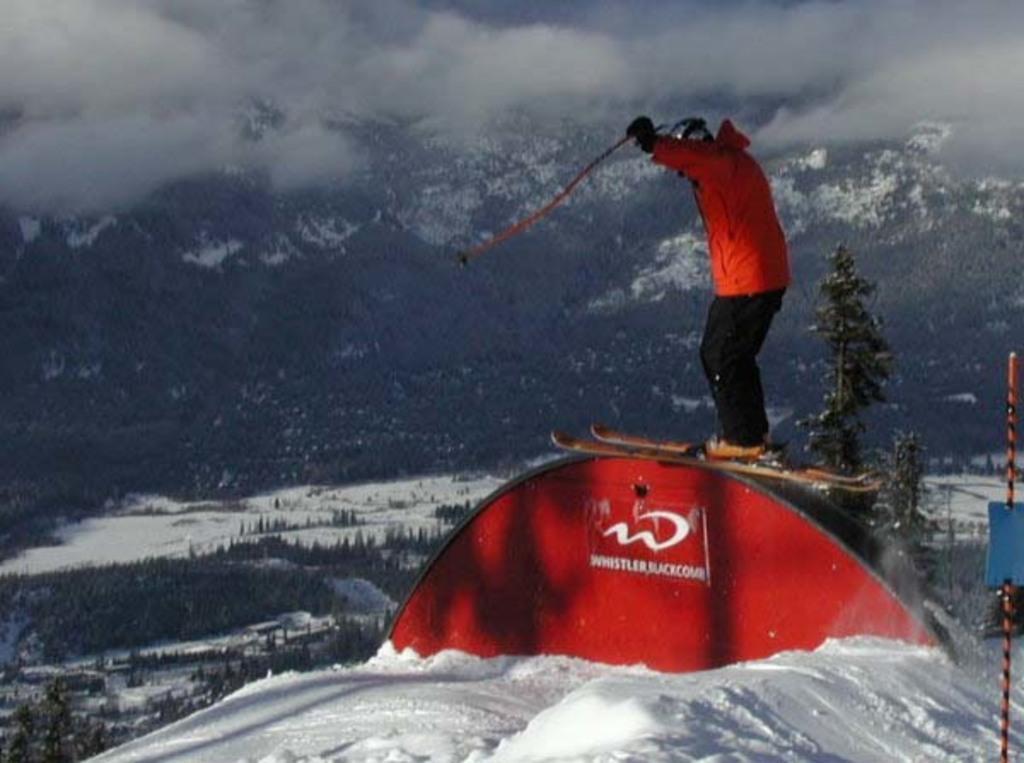Could you give a brief overview of what you see in this image? In this image, we can see a person holding some object is standing on a red colored object. We can see some trees, plants and mountains. We can see the ground covered with snow. We can also see the clouds. We can also see an object on the right. 